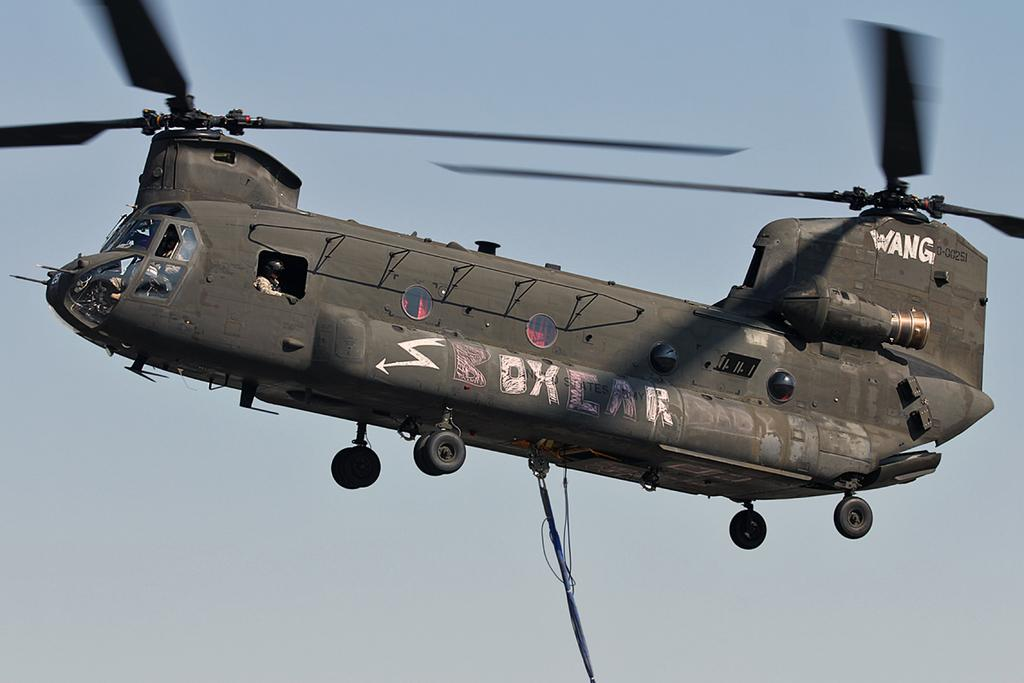<image>
Describe the image concisely. A military type helicoper appears to be flying and has the words Wang and Boxcar painted on the side. 